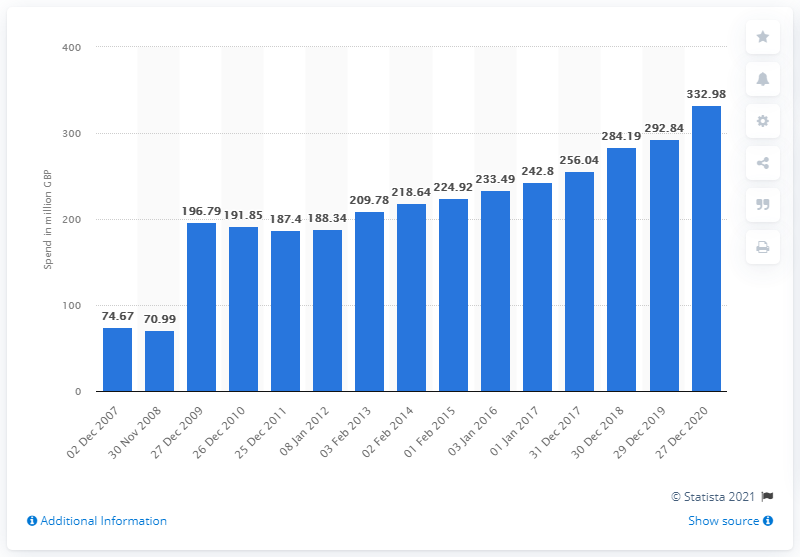Give some essential details in this illustration. In December 2019, the amount of pounds spent on chilled prepared fish in the UK was 292.84 pounds. 